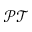<formula> <loc_0><loc_0><loc_500><loc_500>\mathcal { P T }</formula> 